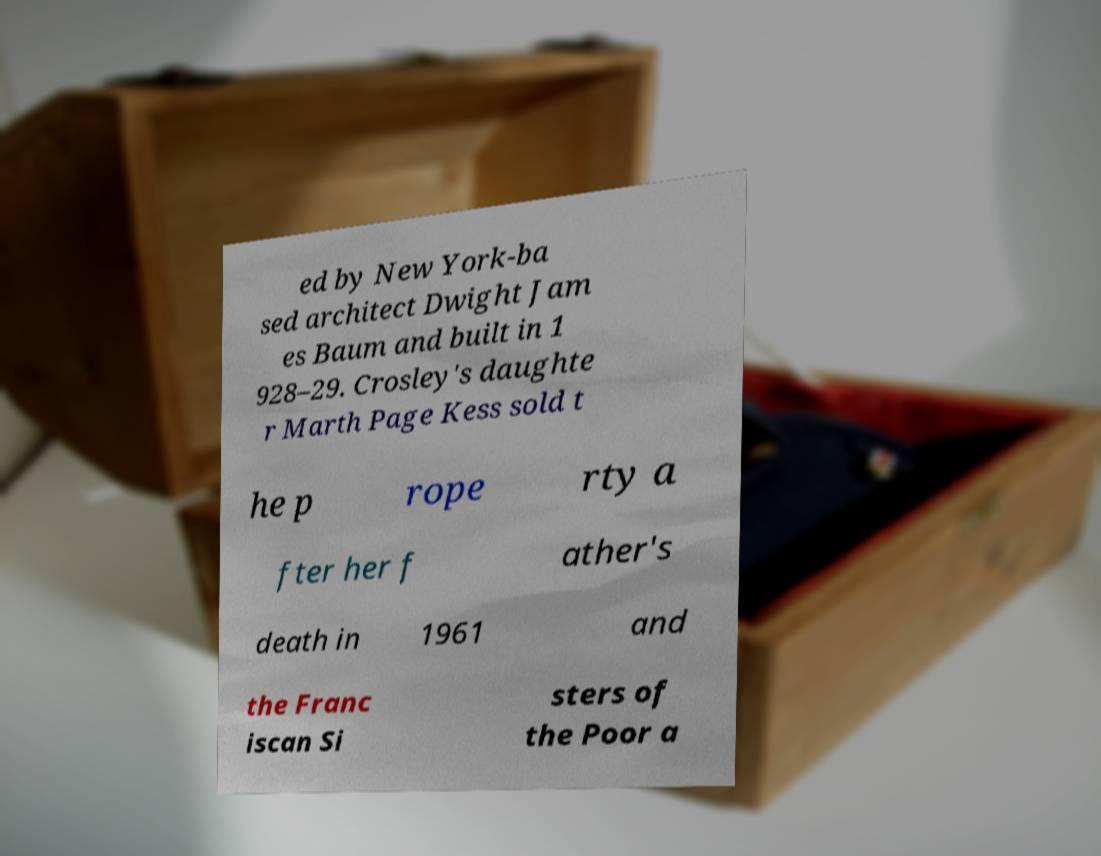Could you assist in decoding the text presented in this image and type it out clearly? ed by New York-ba sed architect Dwight Jam es Baum and built in 1 928–29. Crosley's daughte r Marth Page Kess sold t he p rope rty a fter her f ather's death in 1961 and the Franc iscan Si sters of the Poor a 